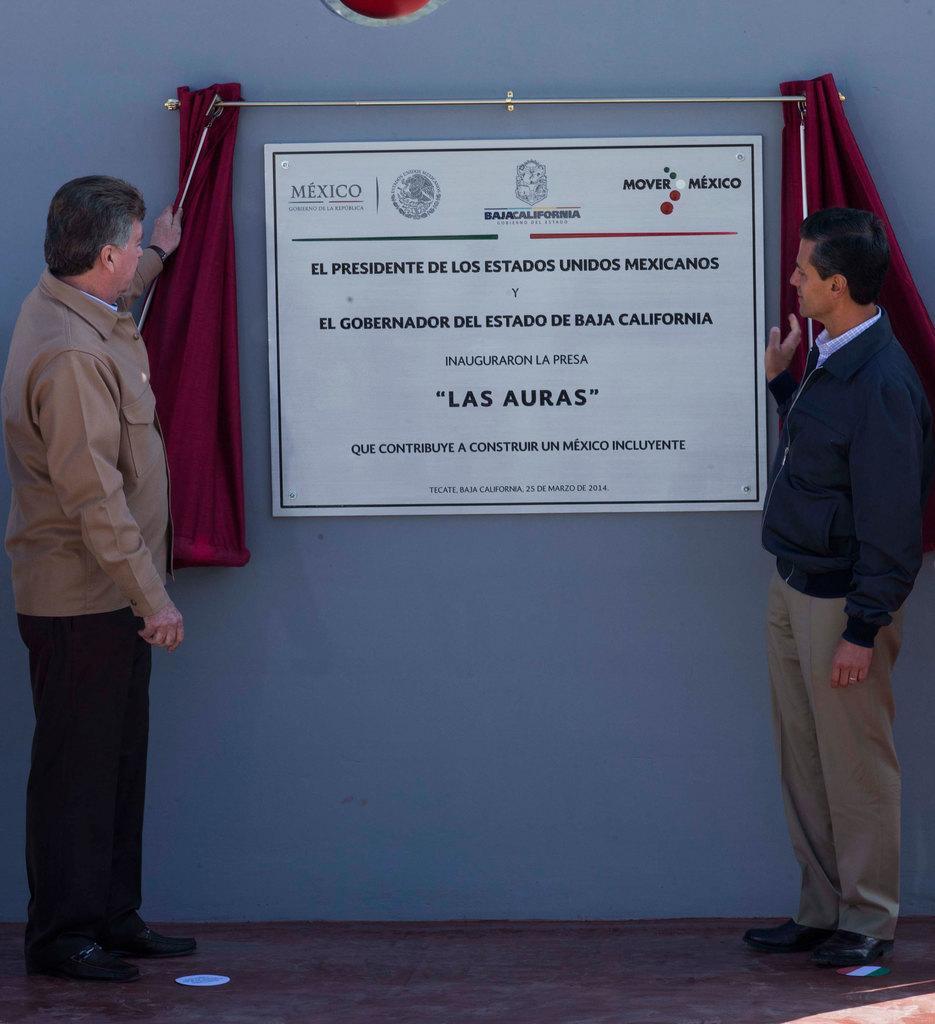Can you describe this image briefly? In the background we can see the wall. In this picture we can see curtains, stand and we can see a board with some information. We can see men standing and they both are staring at a board. 